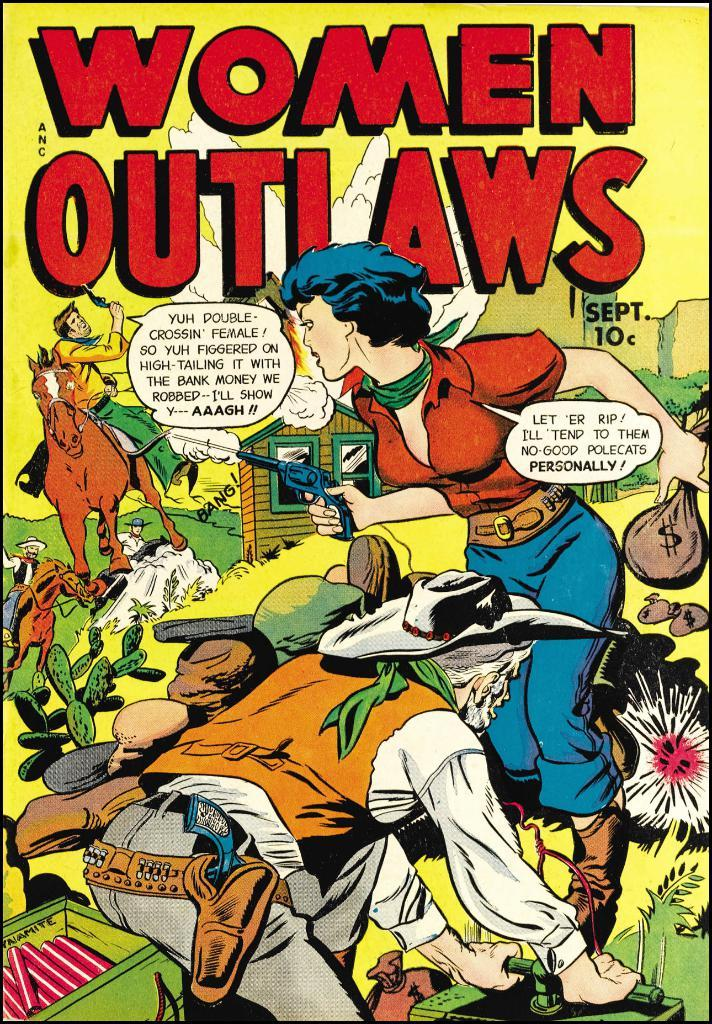Provide a one-sentence caption for the provided image. A comic book with the title Women Outlaws. 